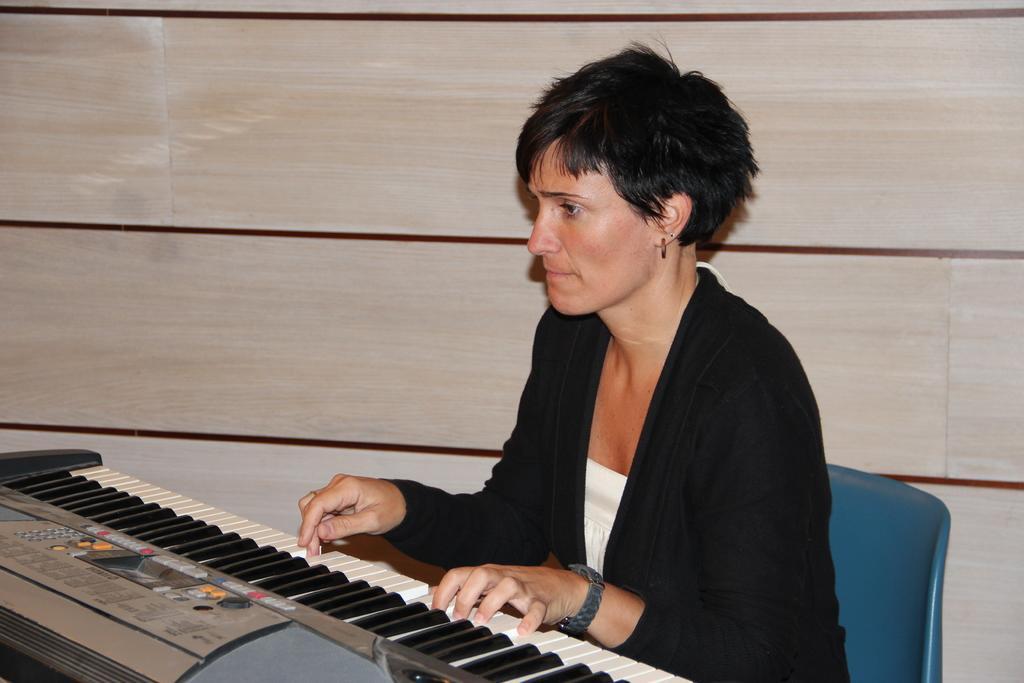Describe this image in one or two sentences. In this image i can see a woman sitting and playing a piano at the back ground i can see a wall. 